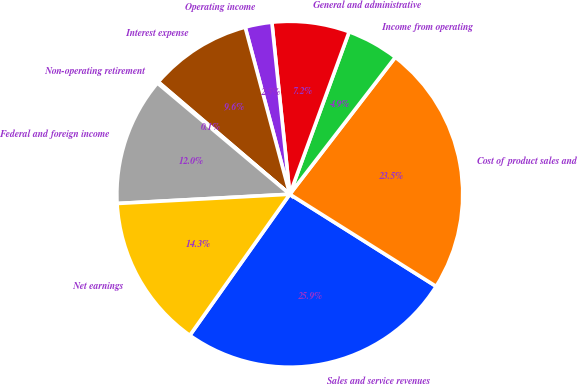Convert chart. <chart><loc_0><loc_0><loc_500><loc_500><pie_chart><fcel>Sales and service revenues<fcel>Cost of product sales and<fcel>Income from operating<fcel>General and administrative<fcel>Operating income<fcel>Interest expense<fcel>Non-operating retirement<fcel>Federal and foreign income<fcel>Net earnings<nl><fcel>25.87%<fcel>23.5%<fcel>4.87%<fcel>7.23%<fcel>2.5%<fcel>9.6%<fcel>0.13%<fcel>11.97%<fcel>14.34%<nl></chart> 